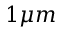<formula> <loc_0><loc_0><loc_500><loc_500>1 \mu m</formula> 